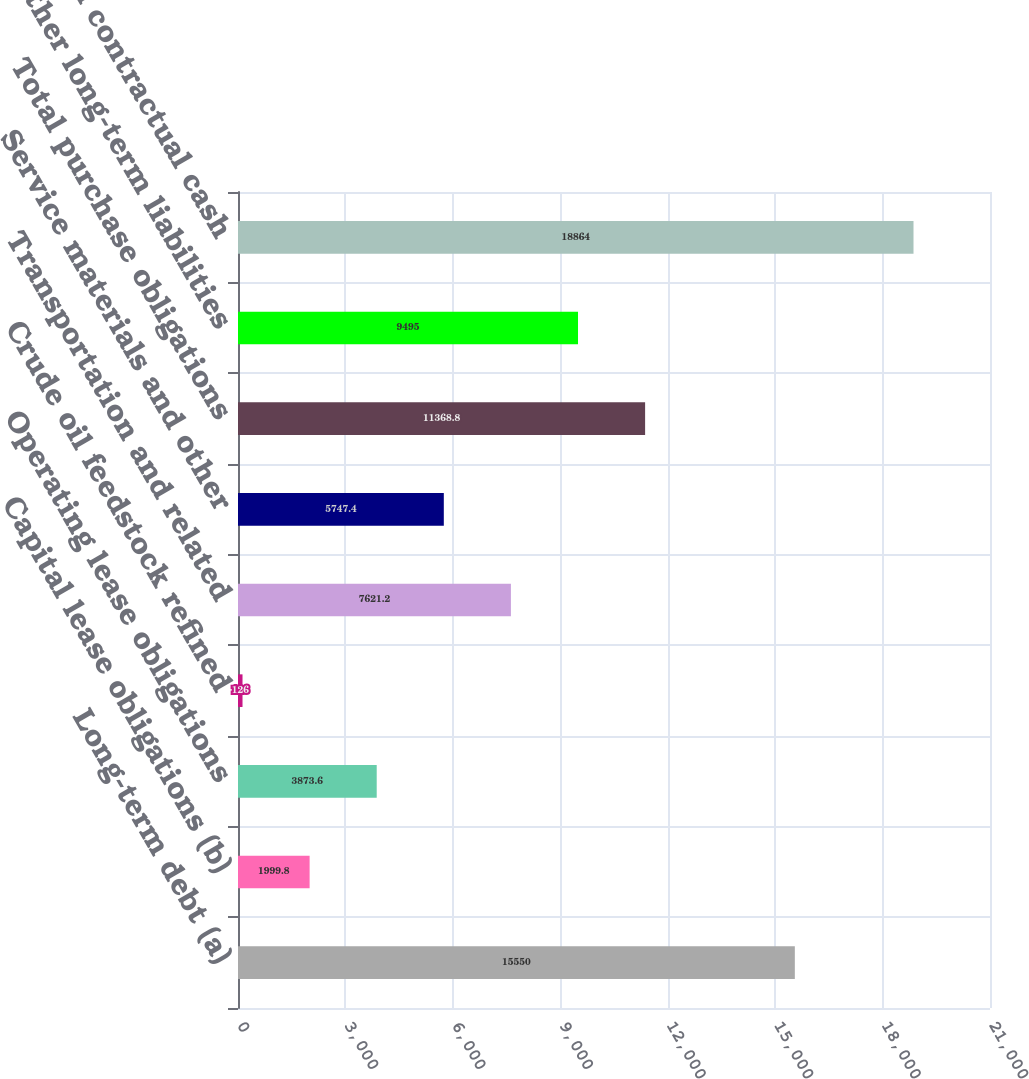Convert chart. <chart><loc_0><loc_0><loc_500><loc_500><bar_chart><fcel>Long-term debt (a)<fcel>Capital lease obligations (b)<fcel>Operating lease obligations<fcel>Crude oil feedstock refined<fcel>Transportation and related<fcel>Service materials and other<fcel>Total purchase obligations<fcel>Other long-term liabilities<fcel>Total contractual cash<nl><fcel>15550<fcel>1999.8<fcel>3873.6<fcel>126<fcel>7621.2<fcel>5747.4<fcel>11368.8<fcel>9495<fcel>18864<nl></chart> 